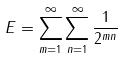<formula> <loc_0><loc_0><loc_500><loc_500>E = \sum _ { m = 1 } ^ { \infty } \sum _ { n = 1 } ^ { \infty } \frac { 1 } { 2 ^ { m n } }</formula> 